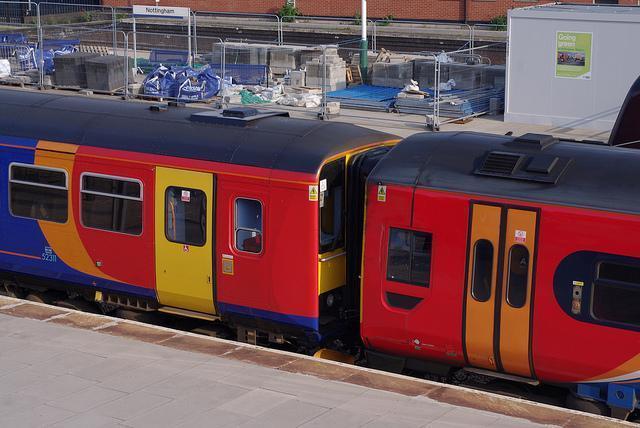How many people are riding the elephant?
Give a very brief answer. 0. 